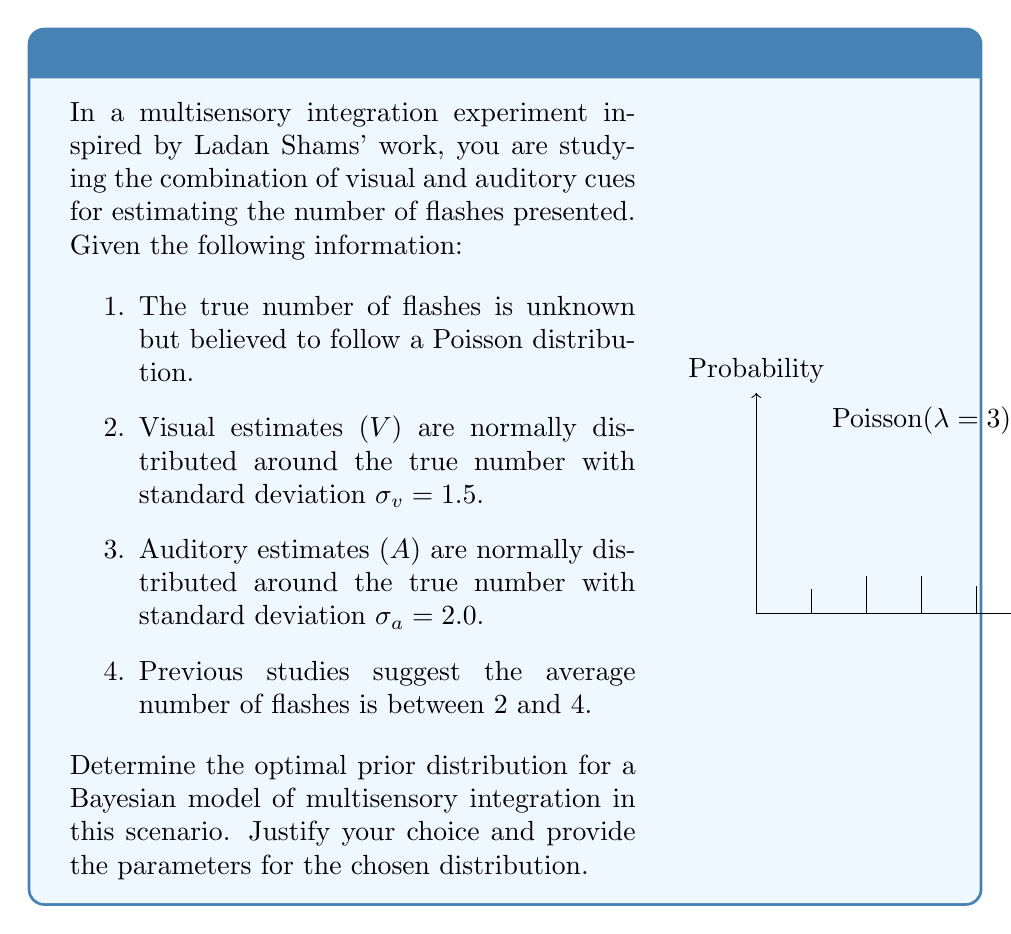Show me your answer to this math problem. To determine the optimal prior distribution for this Bayesian model of multisensory integration, we need to consider the given information and choose a distribution that best represents our prior beliefs about the true number of flashes. Let's analyze the information step-by-step:

1. The true number of flashes follows a Poisson distribution. This suggests that our prior should be compatible with discrete, non-negative integers.

2. The visual and auditory estimates are normally distributed around the true number. This information will be useful for the likelihood function but doesn't directly inform our prior.

3. Previous studies suggest the average number of flashes is between 2 and 4. This gives us a range for the expected value of our prior distribution.

4. The Poisson distribution is a natural choice for modeling count data, which aligns with the nature of our experiment (counting flashes).

Given these considerations, the optimal prior distribution for this scenario is a Gamma distribution. The Gamma distribution is the conjugate prior for the Poisson distribution, which makes it mathematically convenient for Bayesian inference. Moreover, it can be parameterized to reflect our prior beliefs about the average number of flashes.

To determine the parameters of the Gamma distribution, we'll use the shape-rate parameterization: Gamma(α, β), where:

- α (shape parameter) > 0
- β (rate parameter) > 0
- The mean of the distribution is α/β
- The variance is α/β^2

We want the mean to be between 2 and 4, so let's choose the middle value, 3, as our target mean. We also want a relatively informative prior, but not too strong. Let's choose a variance of 1, which allows for a reasonable spread around our expected mean.

Solving the equations:
1. Mean = α/β = 3
2. Variance = α/β^2 = 1

We get:
α = 9
β = 3

Therefore, our optimal prior distribution is Gamma(9, 3), which has a mean of 3 and a variance of 1.

This prior:
1. Is compatible with the Poisson likelihood (conjugate prior)
2. Has a mean within the suggested range (2 to 4)
3. Allows for uncertainty in our prior belief
4. Is mathematically convenient for Bayesian inference in this multisensory integration model
Answer: Gamma(9, 3) 